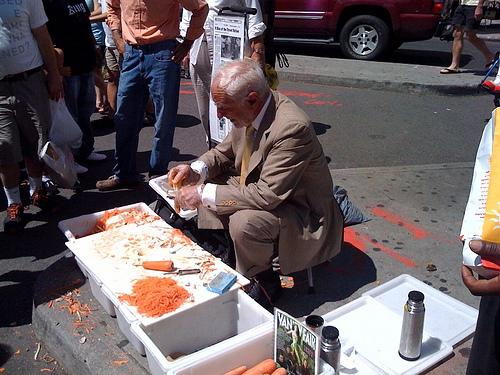What is the orange item? carrot 